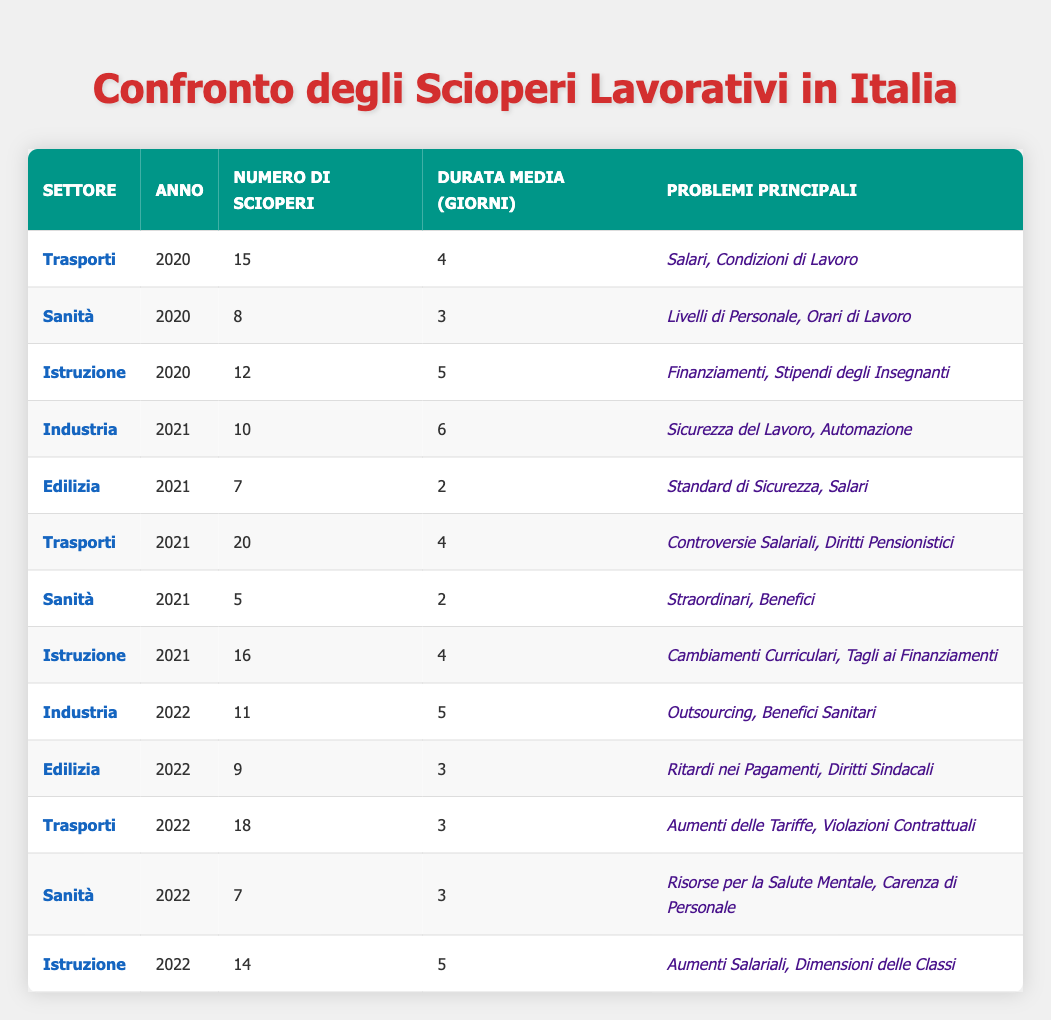What sector had the highest number of strikes in 2021? In 2021, the Transportation sector had the highest number of strikes with a total of 20 incidents. The other sectors had fewer strikes.
Answer: Transportation What was the average duration of strikes in the Manufacturing sector in 2022? In 2022, the Manufacturing sector had 11 strikes with an average duration of 5 days. Thus, the average duration is directly stated in the table.
Answer: 5 days How many strikes did the Education sector have across all years? The total number of strikes in the Education sector is calculated by summing strikes from each year: 12 (2020) + 16 (2021) + 14 (2022) = 42.
Answer: 42 Did the Healthcare sector have more or fewer strikes in 2021 compared to 2020? The Healthcare sector had 8 strikes in 2020 and 5 strikes in 2021. Therefore, the number of strikes in 2021 is fewer.
Answer: Fewer Which sector experienced the maximum average duration of strikes in 2021? In 2021, the Manufacturing sector had an average strike duration of 6 days, the highest among all sectors that year.
Answer: Manufacturing What percentage of the total strikes in 2021 were related to the Education sector? In 2021, there were a total of 20 (Transportation) + 5 (Healthcare) + 10 (Manufacturing) + 7 (Construction) + 16 (Education) = 58 strikes. Thus, the percentage from the Education sector is (16/58) * 100 ≈ 27.59%.
Answer: Approximately 27.59% How many more strikes did the Transportation sector have in 2022 compared to 2021? The Transportation sector had 18 strikes in 2022 and 20 in 2021. Therefore, there were 18 - 20 = -2 more strikes in 2022, indicating a decrease.
Answer: 2 fewer strikes What were the main issues of the strikes in the Construction sector in 2021? The main issues identified for the Construction sector in 2021 were Safety Standards and Wages, as specified in the table for that sector and year.
Answer: Safety Standards, Wages Which year saw the largest number of strikes in the Healthcare sector? In the Healthcare sector, 2020 had 8 strikes, 2021 had 5 strikes, and 2022 had 7 strikes. Thus, 2020 witnessed the largest number of strikes.
Answer: 2020 Is the average duration of strikes in the Transportation sector higher in 2022 than in 2021? The average duration for the Transportation sector was 4 days in 2021 and 3 days in 2022. Therefore, the average duration in 2022 is lower.
Answer: No, it is lower 